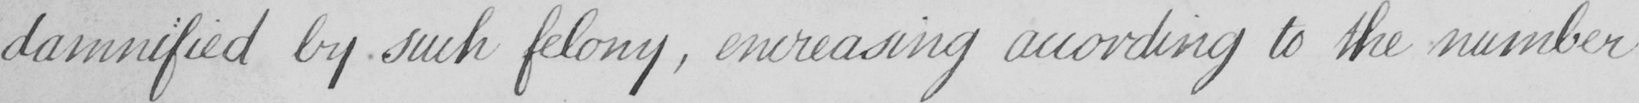Transcribe the text shown in this historical manuscript line. damnified by such felony , encreasing according to the number 